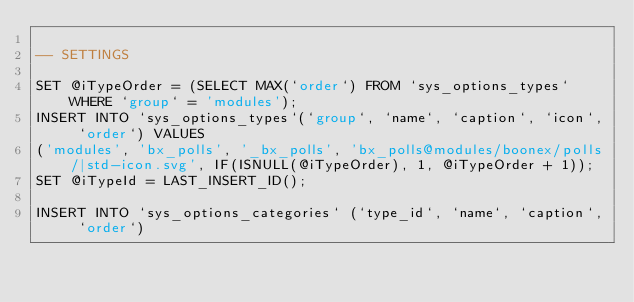<code> <loc_0><loc_0><loc_500><loc_500><_SQL_>
-- SETTINGS

SET @iTypeOrder = (SELECT MAX(`order`) FROM `sys_options_types` WHERE `group` = 'modules');
INSERT INTO `sys_options_types`(`group`, `name`, `caption`, `icon`, `order`) VALUES 
('modules', 'bx_polls', '_bx_polls', 'bx_polls@modules/boonex/polls/|std-icon.svg', IF(ISNULL(@iTypeOrder), 1, @iTypeOrder + 1));
SET @iTypeId = LAST_INSERT_ID();

INSERT INTO `sys_options_categories` (`type_id`, `name`, `caption`, `order`)</code> 